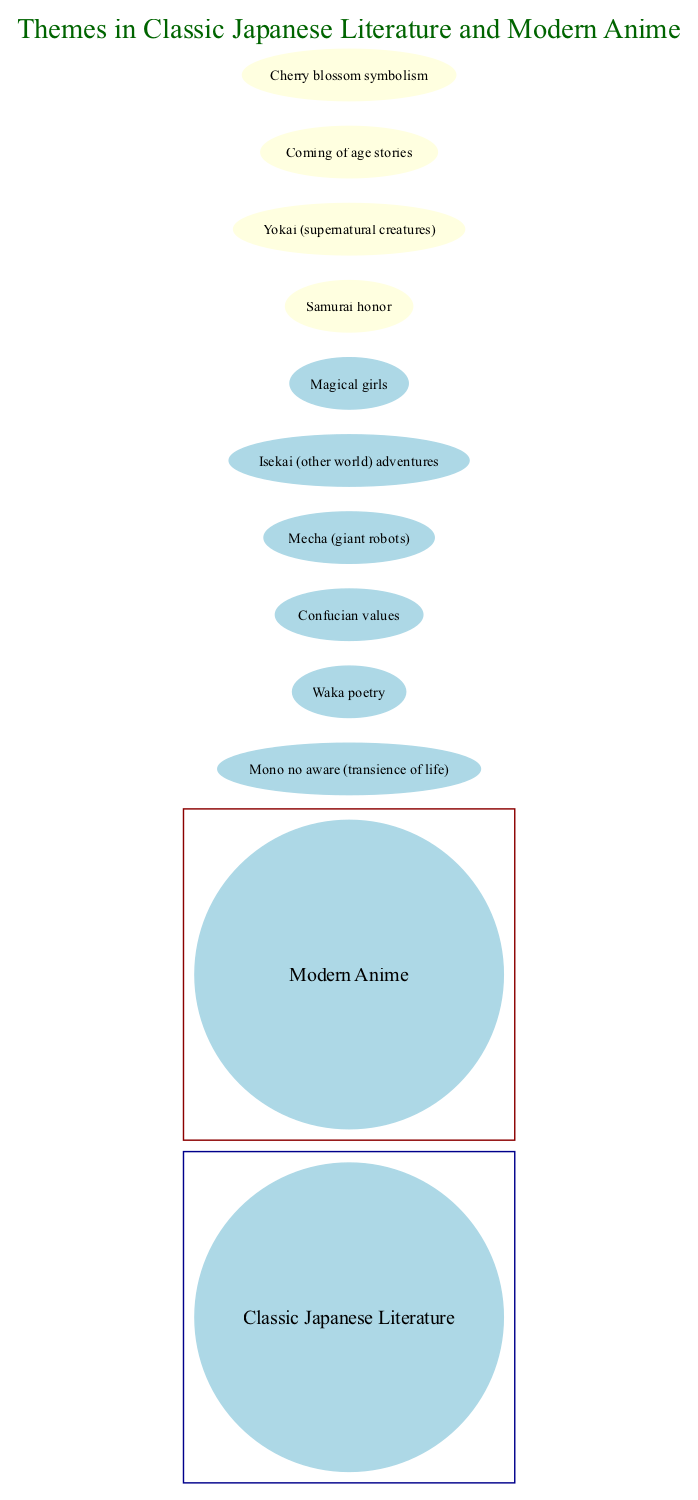What is one theme unique to Classic Japanese Literature? The left circle represents themes specific to Classic Japanese Literature. Among the listed themes, "Mono no aware (transience of life)" is included, which is not shared with Modern Anime.
Answer: Mono no aware (transience of life) What is one theme unique to Modern Anime? The right circle depicts themes that are exclusive to Modern Anime. "Mecha (giant robots)" is identified as a theme that does not appear in Classic Japanese Literature.
Answer: Mecha (giant robots) How many themes are in the intersection of both circles? The intersection represents themes shared between Classic Japanese Literature and Modern Anime. There are four themes listed in the intersection: "Samurai honor," "Yokai (supernatural creatures)," "Coming of age stories," and "Cherry blossom symbolism."
Answer: 4 What theme involves supernatural elements? The intersection includes "Yokai (supernatural creatures)," which is a theme recognized in both Classic Japanese Literature and Modern Anime, indicating the blending of cultural folklore with modern storytelling.
Answer: Yokai (supernatural creatures) Which theme in Modern Anime involves adventures in another world? The right circle includes the theme "Isekai (other world) adventures," which is specific to Modern Anime and suggests narratives that transport characters into different dimensions or realms.
Answer: Isekai (other world) adventures What two themes are shared between Classic Japanese Literature and Modern Anime? In the intersection of the two circles, "Samurai honor" and "Coming of age stories" are themes that exist in both Classic Japanese Literature and Modern Anime, highlighting common narrative topics.
Answer: Samurai honor, Coming of age stories What literary form is unique to Classic Japanese Literature? The left circle showcases "Waka poetry," which is a traditional form of Japanese poetry and is not observed in Modern Anime, emphasizing the distinct cultural literary practices.
Answer: Waka poetry What is a common symbolic element shared by both genres? "Cherry blossom symbolism" is found in the intersection, representing a culturally significant motif deeply rooted in Japanese traditions, which both Classic Literature and Modern Anime utilize.
Answer: Cherry blossom symbolism 